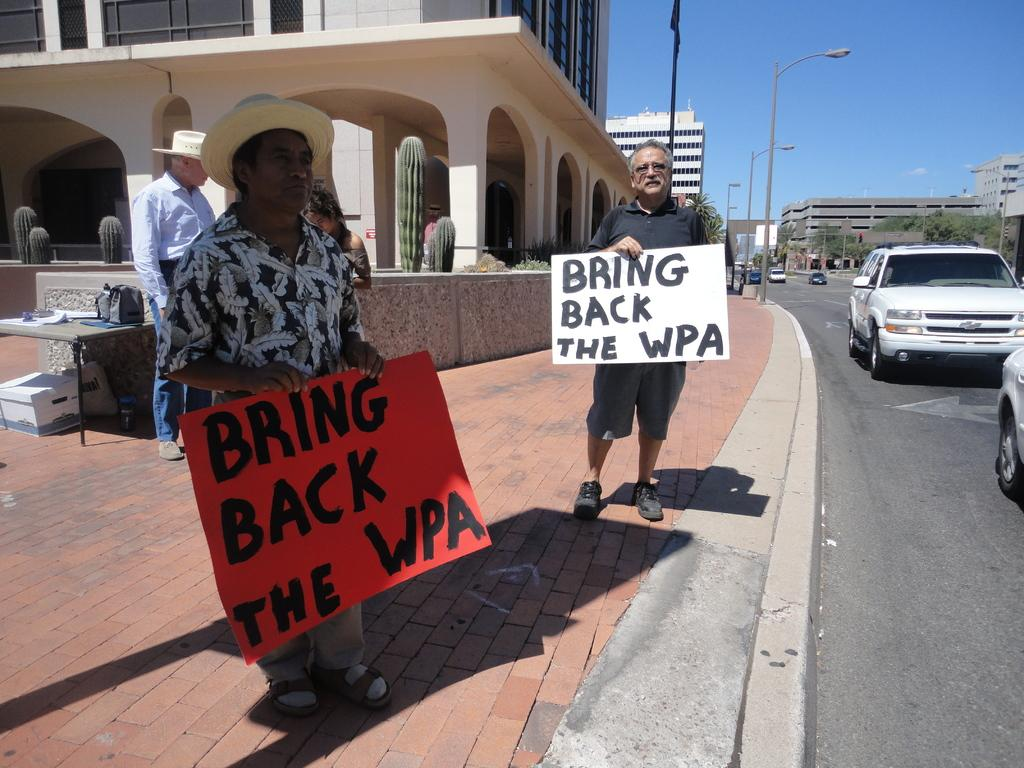Who is present in the image? There is a man in the image. What is the man holding in his hands? The man is holding a board in his hands. What can be seen on the road in the image? There are vehicles on the road in the image. What type of structures are visible in the image? There are buildings visible in the image. What type of quartz can be seen in the man's pocket in the image? There is no quartz visible in the image, nor is there any indication that the man has a pocket. 